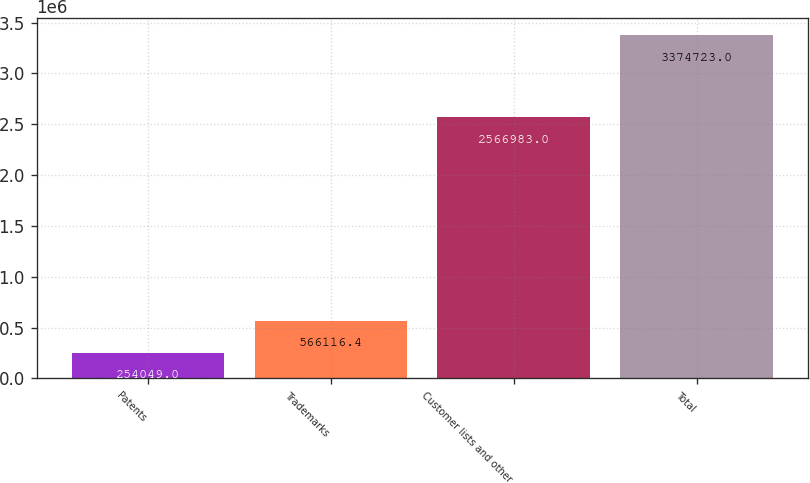Convert chart. <chart><loc_0><loc_0><loc_500><loc_500><bar_chart><fcel>Patents<fcel>Trademarks<fcel>Customer lists and other<fcel>Total<nl><fcel>254049<fcel>566116<fcel>2.56698e+06<fcel>3.37472e+06<nl></chart> 